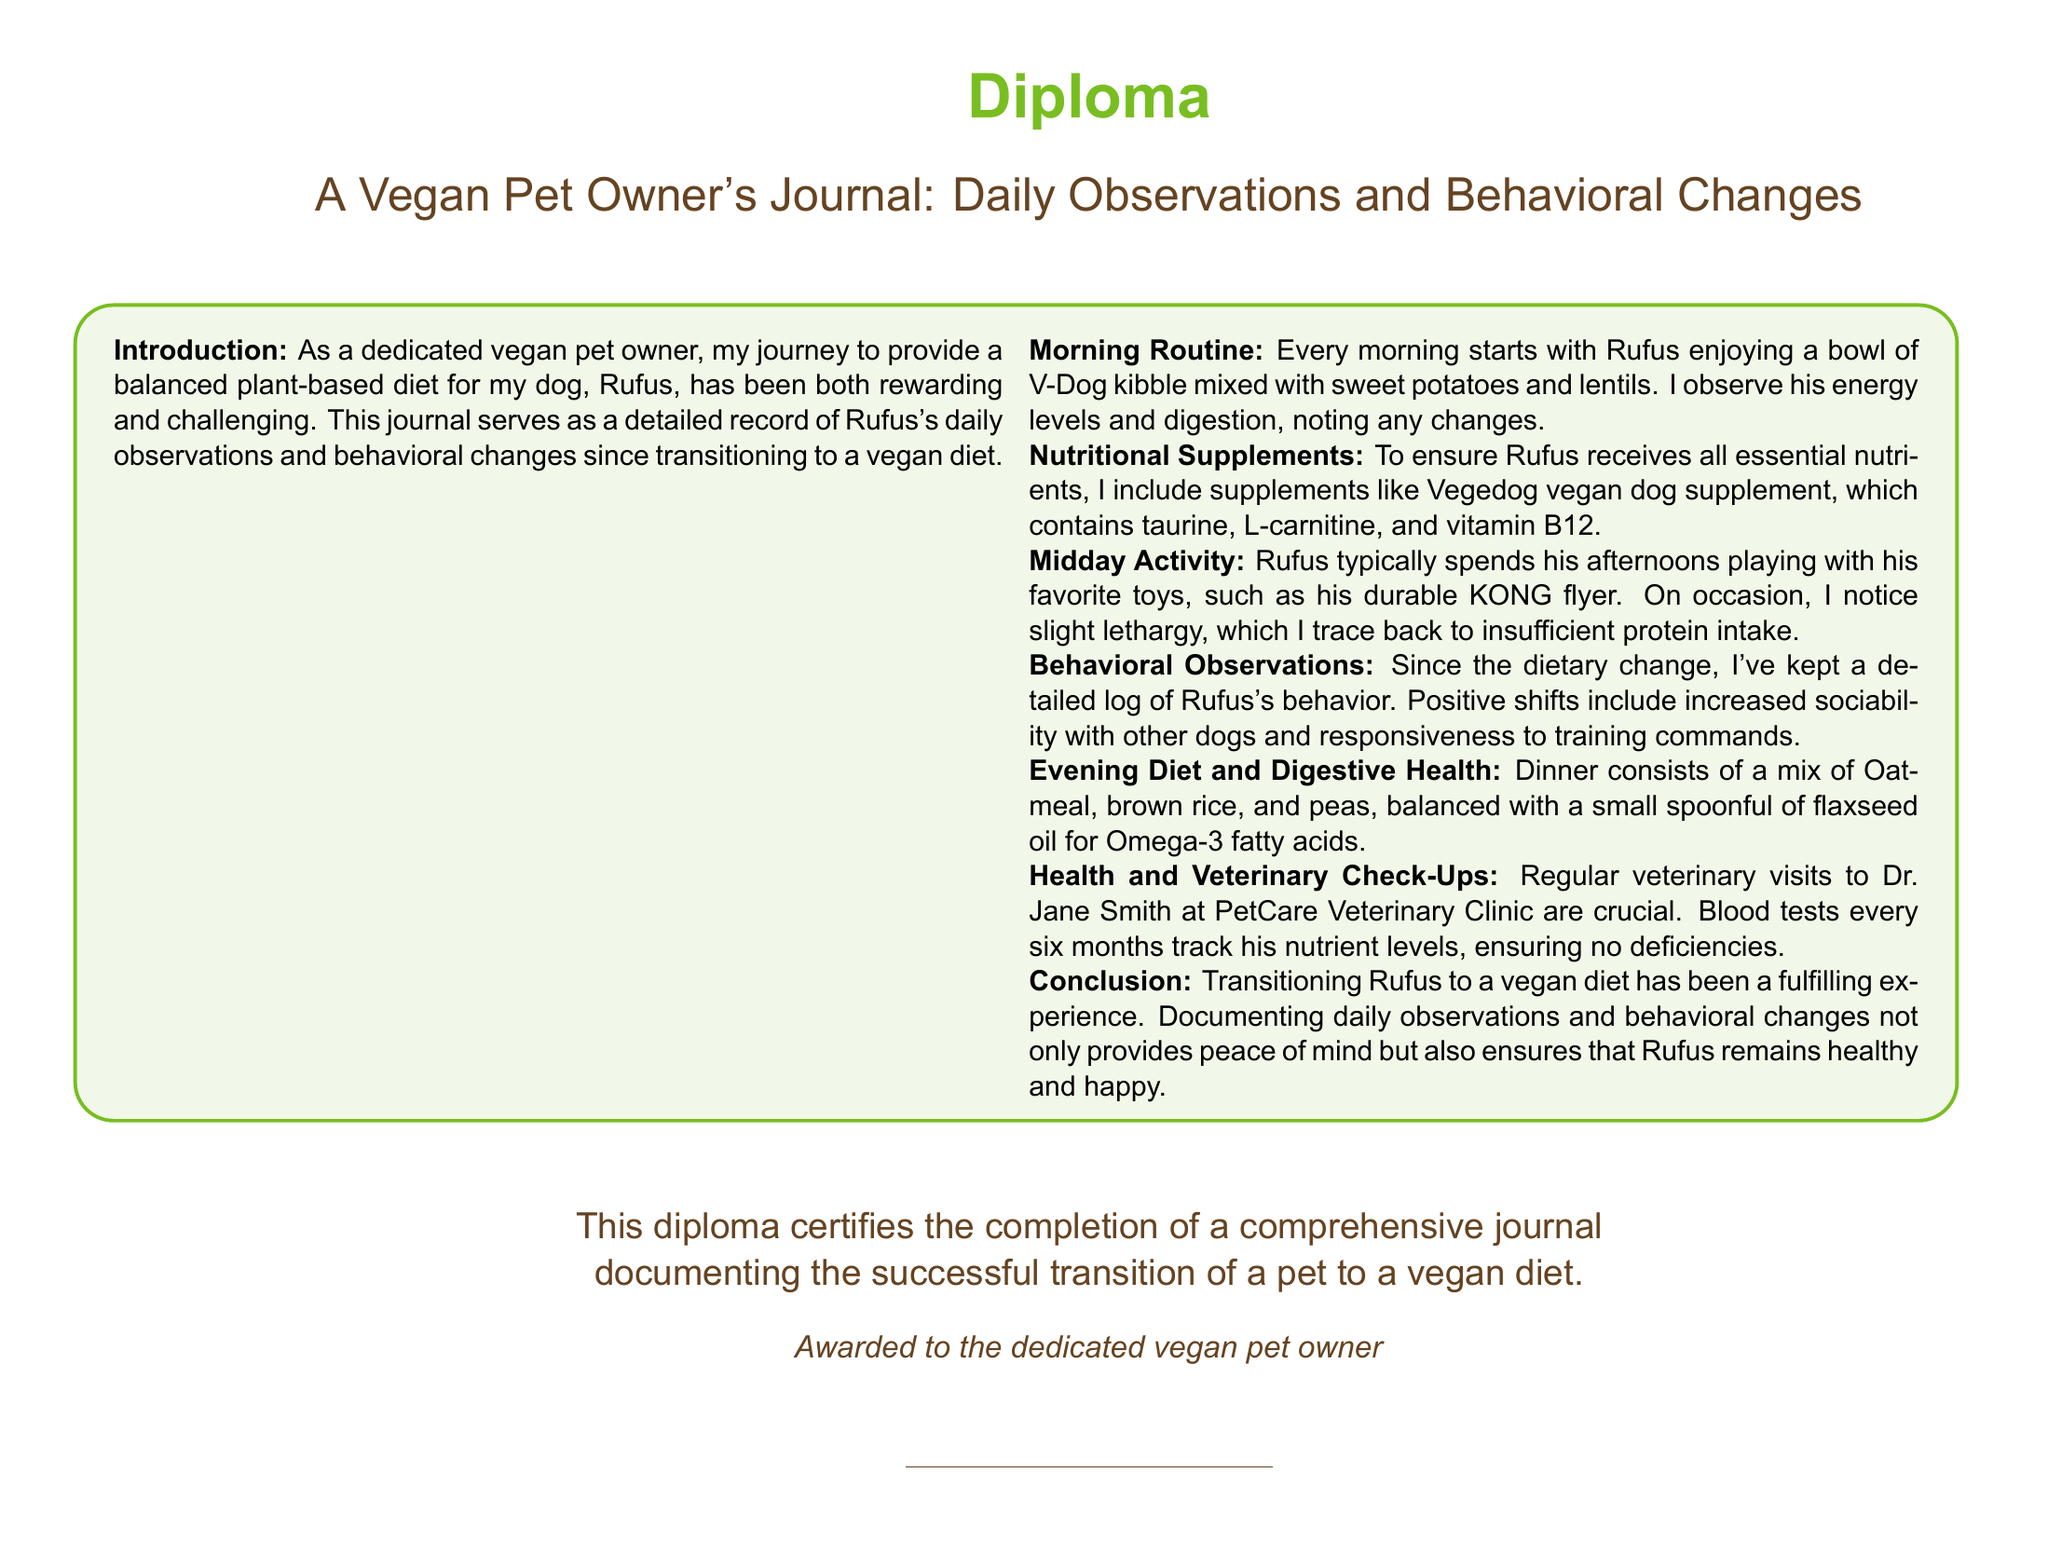What is the title of the journal? The title of the journal is the main heading of the document that describes its content and purpose.
Answer: A Vegan Pet Owner's Journal: Daily Observations and Behavioral Changes Who is the dog mentioned in the journal? The journal specifically refers to a dog named Rufus that the owner is caring for.
Answer: Rufus Which veterinary clinic does the author visit? The author mentions the name of the veterinary clinic for regular check-ups for Rufus.
Answer: PetCare Veterinary Clinic What is included in Rufus's evening diet? This question focuses on the specific components of Rufus's diet during the evening meal as detailed in the journal.
Answer: Oatmeal, brown rice, and peas How often does Rufus have blood tests? The journal indicates the frequency of blood tests that Rufus undergoes to track his nutrient levels.
Answer: Every six months What type of toys does Rufus play with? This question asks for the type or brand of toys mentioned in the journal that Rufus enjoys playing with.
Answer: KONG flyer What is the purpose of the journal? The journal's purpose is outlined in the introduction, explaining why it has been created.
Answer: Documenting the successful transition of a pet to a vegan diet What supplement is mentioned in the diet? This question addresses a specific supplement included in Rufus's diet to ensure he receives necessary nutrients.
Answer: Vegedog vegan dog supplement 